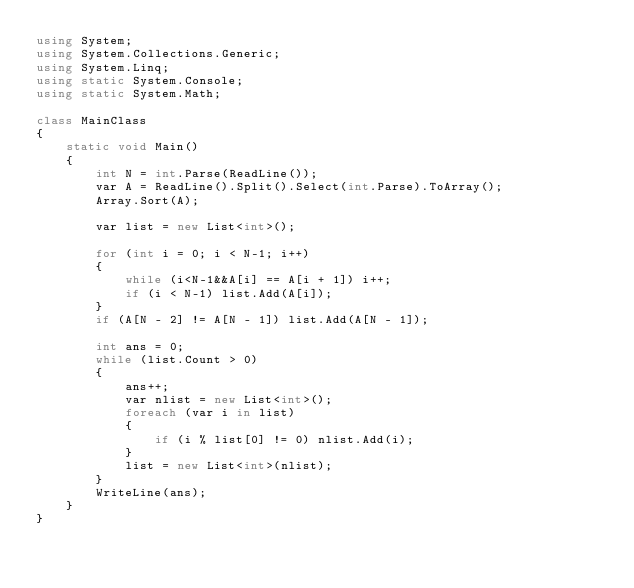<code> <loc_0><loc_0><loc_500><loc_500><_C#_>using System;
using System.Collections.Generic;
using System.Linq;
using static System.Console;
using static System.Math;

class MainClass
{
    static void Main()
    {
        int N = int.Parse(ReadLine());
        var A = ReadLine().Split().Select(int.Parse).ToArray();
        Array.Sort(A);

        var list = new List<int>();
        
        for (int i = 0; i < N-1; i++)
        {
            while (i<N-1&&A[i] == A[i + 1]) i++;
            if (i < N-1) list.Add(A[i]);
        }
        if (A[N - 2] != A[N - 1]) list.Add(A[N - 1]);

        int ans = 0;
        while (list.Count > 0)
        {
            ans++;
            var nlist = new List<int>();
            foreach (var i in list)
            {
                if (i % list[0] != 0) nlist.Add(i);
            }
            list = new List<int>(nlist);
        }
        WriteLine(ans);
    }
}
</code> 